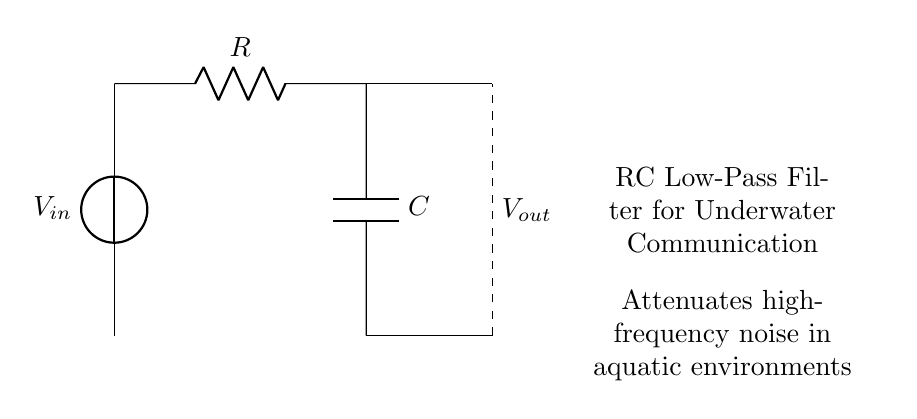What is the input voltage source labeled as in the circuit? The voltage source is labeled as V subscript in. This refers to the input voltage of the RC filter circuit.
Answer: V in What does the resistor in this circuit represent? The resistor, labeled as R, is a key component that limits current flow and helps in determining the cutoff frequency of the filter when combined with the capacitor.
Answer: R What type of filter is this circuit designed as? The circuit is designed as a low-pass filter, which allows low-frequency signals to pass through while attenuating high-frequency signals, useful for underwater communication.
Answer: Low-pass filter What is the function of the capacitor in this RC circuit? The capacitor, labeled as C, stores and releases electrical energy, which in conjunction with the resistor, helps smooth out voltage variations, filtering high-frequency noise in the communication signals.
Answer: Smooths voltage What happens to high-frequency signals in this circuit? High-frequency signals are attenuated, meaning their amplitude is reduced, as the circuit is specifically designed to filter them out for clearer underwater communication.
Answer: Attenuated What are the two main components of this circuit? The two main components are the resistor and the capacitor, which together form the fundamental elements of an RC filter circuit.
Answer: Resistor and capacitor What is the purpose of this RC filter in the context of underwater communication? The purpose of this RC filter is to reduce high-frequency noise, ensuring that low-frequency communication signals are clearly transmitted and received underwater.
Answer: Reduce noise 